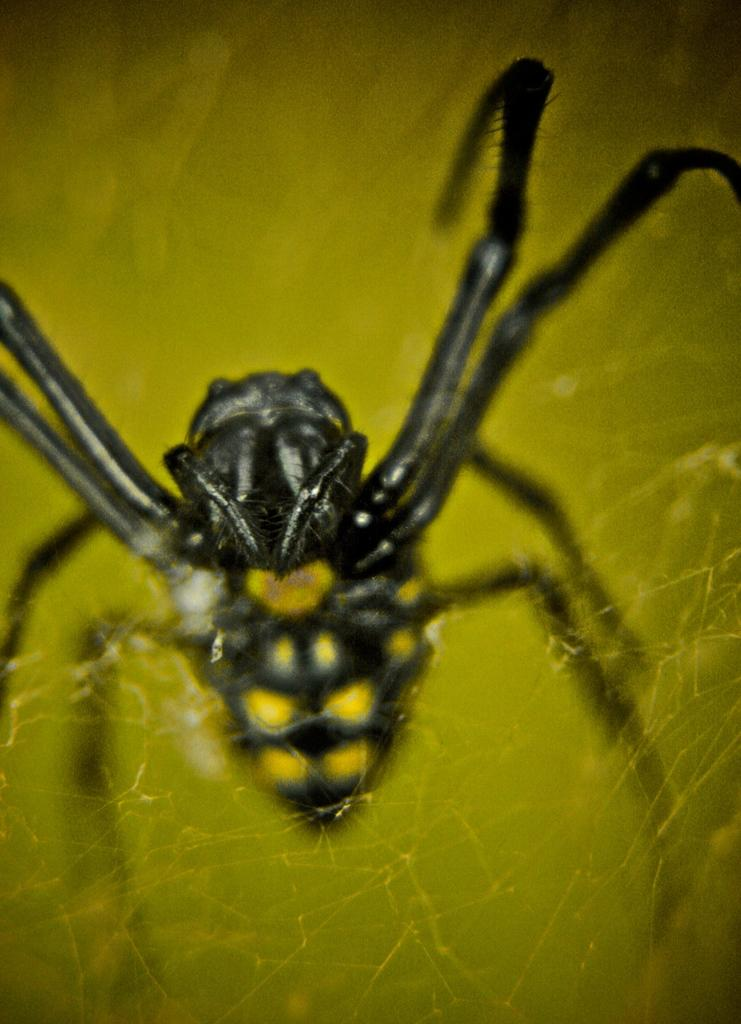What is the main subject of the image? The main subject of the image is a spider. What is associated with the spider in the image? There is a spider web in the image. What type of amusement can be seen in the image? There is no amusement present in the image; it features a spider and a spider web. What mark does the spider leave on the web in the image? There is no indication of a mark left by the spider on the web in the image. 